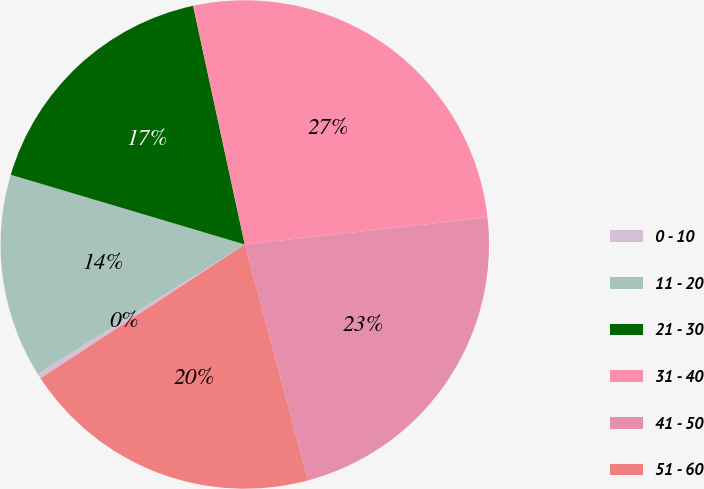Convert chart to OTSL. <chart><loc_0><loc_0><loc_500><loc_500><pie_chart><fcel>0 - 10<fcel>11 - 20<fcel>21 - 30<fcel>31 - 40<fcel>41 - 50<fcel>51 - 60<nl><fcel>0.34%<fcel>13.5%<fcel>17.0%<fcel>26.63%<fcel>22.59%<fcel>19.94%<nl></chart> 